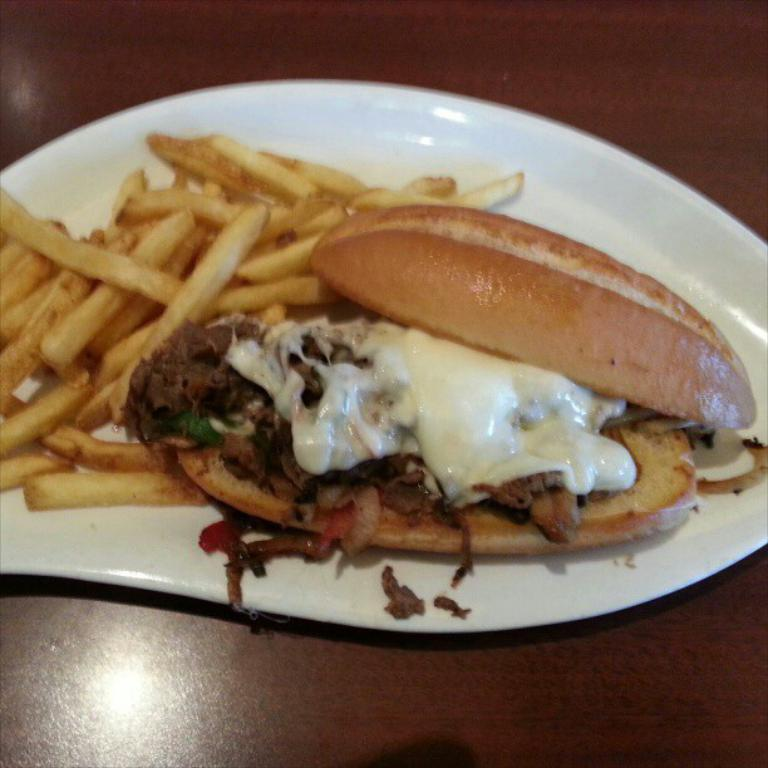What is on the plate in the image? There is a food item on a plate in the image. What color is the plate? The plate is white in color. What is the plate resting on? The plate is on a wooden board. What time of day is it in the image, and how do the hands of the person in the image indicate this? There is no person or indication of time in the image, so it is not possible to determine the time of day or how hands might indicate it. 